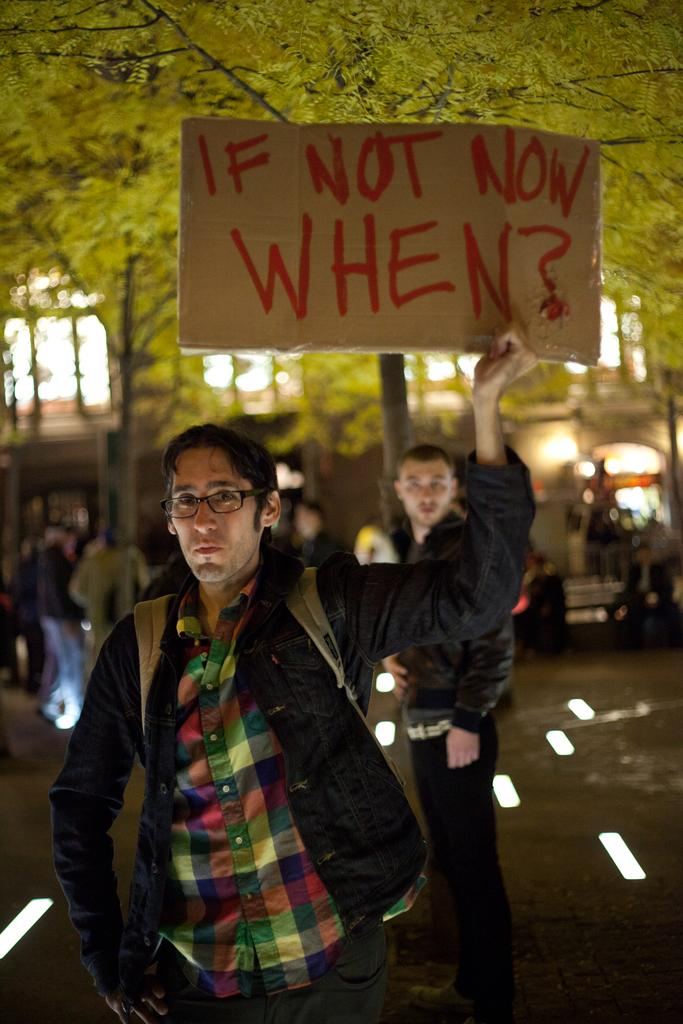What is the person in the image holding? The person is holding a poster. What can be seen in the background of the image? There are people, windows, and a vehicle in the background of the image. How does the person maintain their balance while holding the poster and a hen in the image? There is no hen present in the image, so the person is not holding a hen while maintaining their balance. 